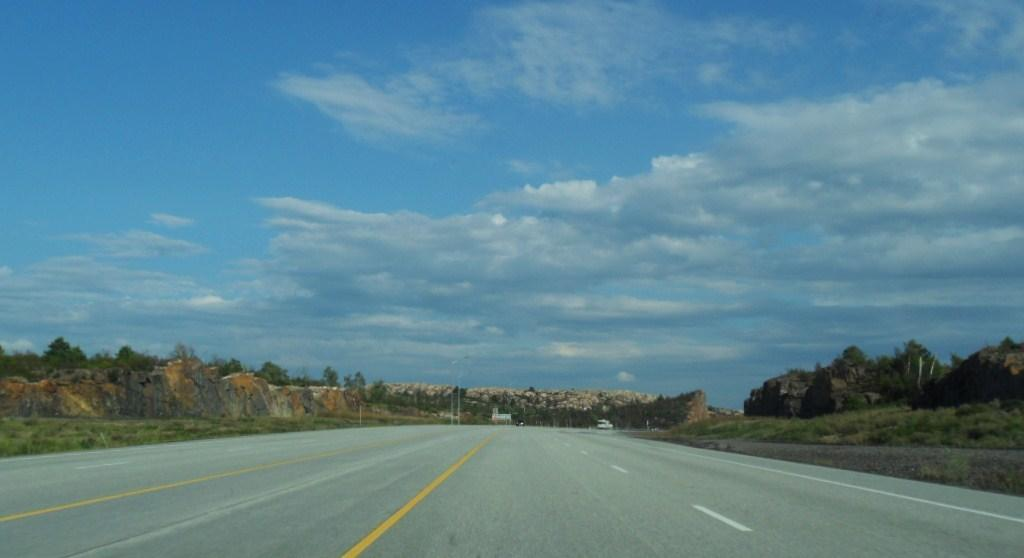What is the main feature of the image? There is a road in the image. What can be seen beside the road? There are trees beside the road. What type of landscape is visible in the image? There are hills in the image. What is happening on the road in the background? Vehicles are moving on the road in the background. What other elements can be seen in the background? Trees and hills are visible in the background. How would you describe the weather in the image? The sky is cloudy in the image. What type of cabbage is growing in the middle of the road? There is no cabbage present in the image, and the road is not a place where cabbage would typically grow. 